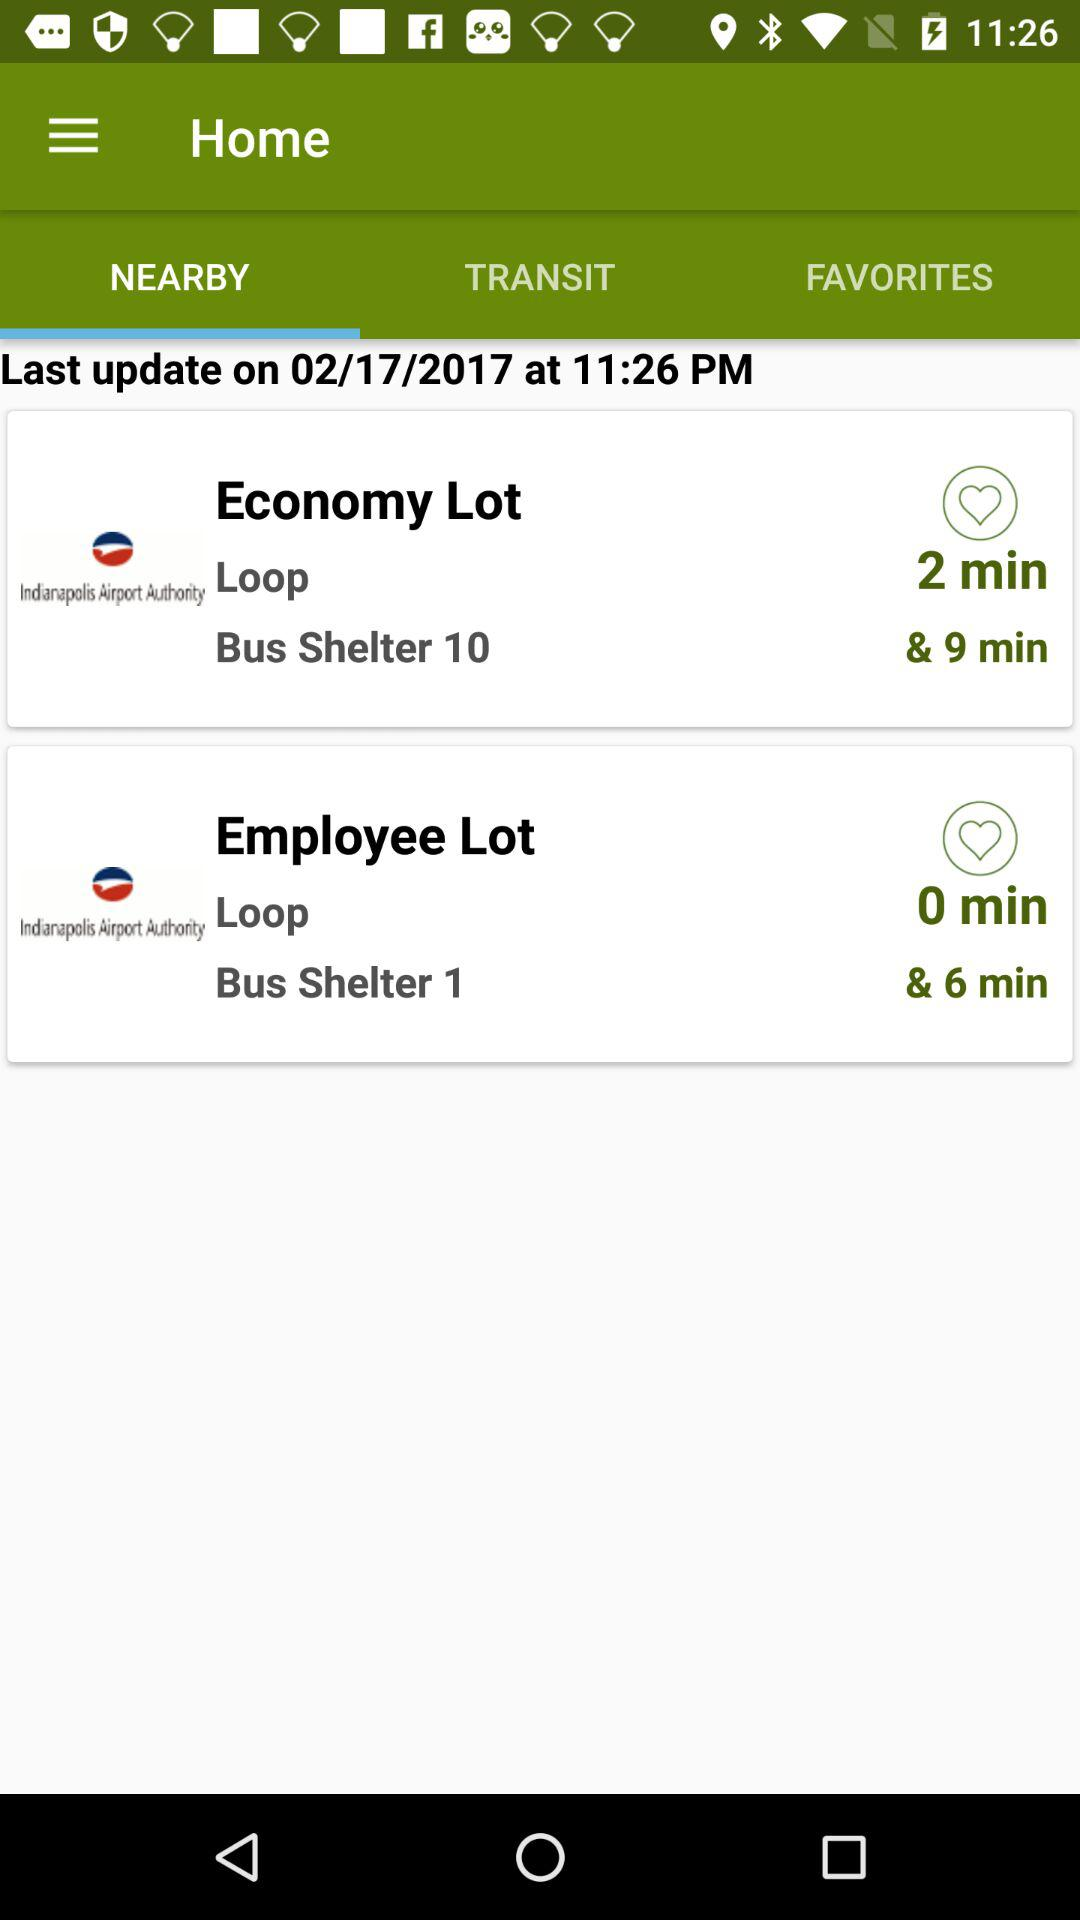Which tab am I using? You are using "NEARBY" tab. 